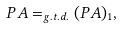<formula> <loc_0><loc_0><loc_500><loc_500>P A = _ { g . t . d . } ( P A ) _ { 1 } ,</formula> 